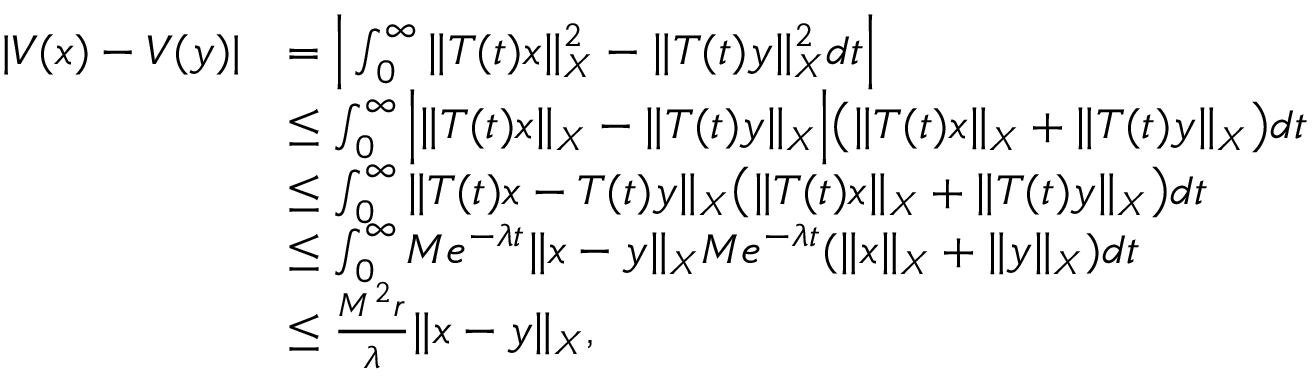<formula> <loc_0><loc_0><loc_500><loc_500>\begin{array} { r l } { | V ( x ) - V ( y ) | } & { = \left | \int _ { 0 } ^ { \infty } \| T ( t ) x \| _ { X } ^ { 2 } - \| T ( t ) y \| _ { X } ^ { 2 } d t \right | } \\ & { \leq \int _ { 0 } ^ { \infty } \left | \| T ( t ) x \| _ { X } - \| T ( t ) y \| _ { X } \right | \left ( \| T ( t ) x \| _ { X } + \| T ( t ) y \| _ { X } \right ) d t } \\ & { \leq \int _ { 0 } ^ { \infty } \| T ( t ) x - T ( t ) y \| _ { X } \left ( \| T ( t ) x \| _ { X } + \| T ( t ) y \| _ { X } \right ) d t } \\ & { \leq \int _ { 0 } ^ { \infty } M e ^ { - \lambda t } \| x - y \| _ { X } M e ^ { - \lambda t } ( \| x \| _ { X } + \| y \| _ { X } ) d t } \\ & { \leq \frac { M ^ { 2 } r } { \lambda } \| x - y \| _ { X } , } \end{array}</formula> 